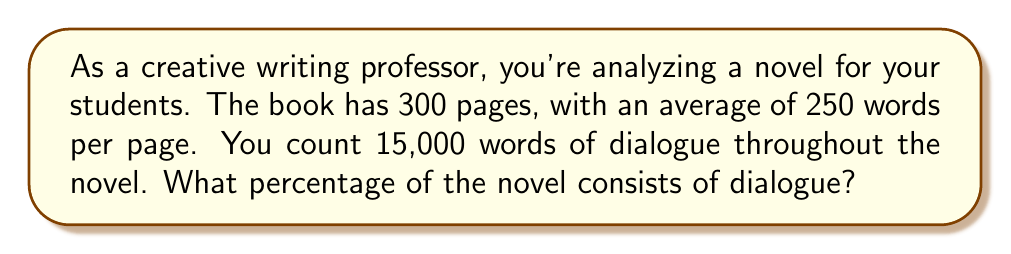Can you solve this math problem? To solve this problem, we'll follow these steps:

1. Calculate the total number of words in the novel:
   $$ \text{Total words} = \text{Pages} \times \text{Words per page} $$
   $$ \text{Total words} = 300 \times 250 = 75,000 \text{ words} $$

2. Set up the percentage calculation:
   $$ \text{Percentage} = \frac{\text{Dialogue words}}{\text{Total words}} \times 100\% $$

3. Plug in the values:
   $$ \text{Percentage} = \frac{15,000}{75,000} \times 100\% $$

4. Simplify the fraction:
   $$ \text{Percentage} = \frac{1}{5} \times 100\% $$

5. Calculate the final percentage:
   $$ \text{Percentage} = 20\% $$

Therefore, 20% of the novel consists of dialogue.
Answer: 20% 